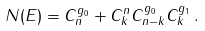Convert formula to latex. <formula><loc_0><loc_0><loc_500><loc_500>N ( E ) = C ^ { g _ { 0 } } _ { n } + C ^ { n } _ { k } C ^ { g _ { 0 } } _ { n - k } C ^ { g _ { 1 } } _ { k } \, .</formula> 